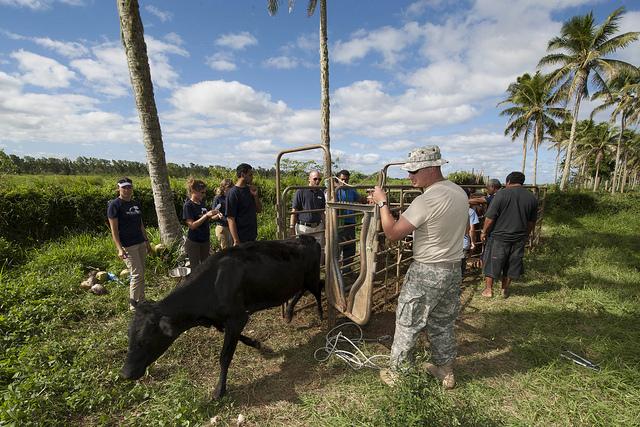Are these animals friends?
Short answer required. Yes. What kind of animal is running?
Quick response, please. Cow. What is going on?
Answer briefly. Helping animals. What animals are these?
Concise answer only. Cows. What style of pants is the man in the hat wearing?
Keep it brief. Camouflage. Is there a car in the photo?
Keep it brief. No. Is this a petting zoo?
Keep it brief. No. Are the men dressed in uniform?
Be succinct. No. What type of animal is this?
Write a very short answer. Cow. Which hand is he pointing with?
Write a very short answer. Left. Is the man proud of his cows?
Keep it brief. Yes. 